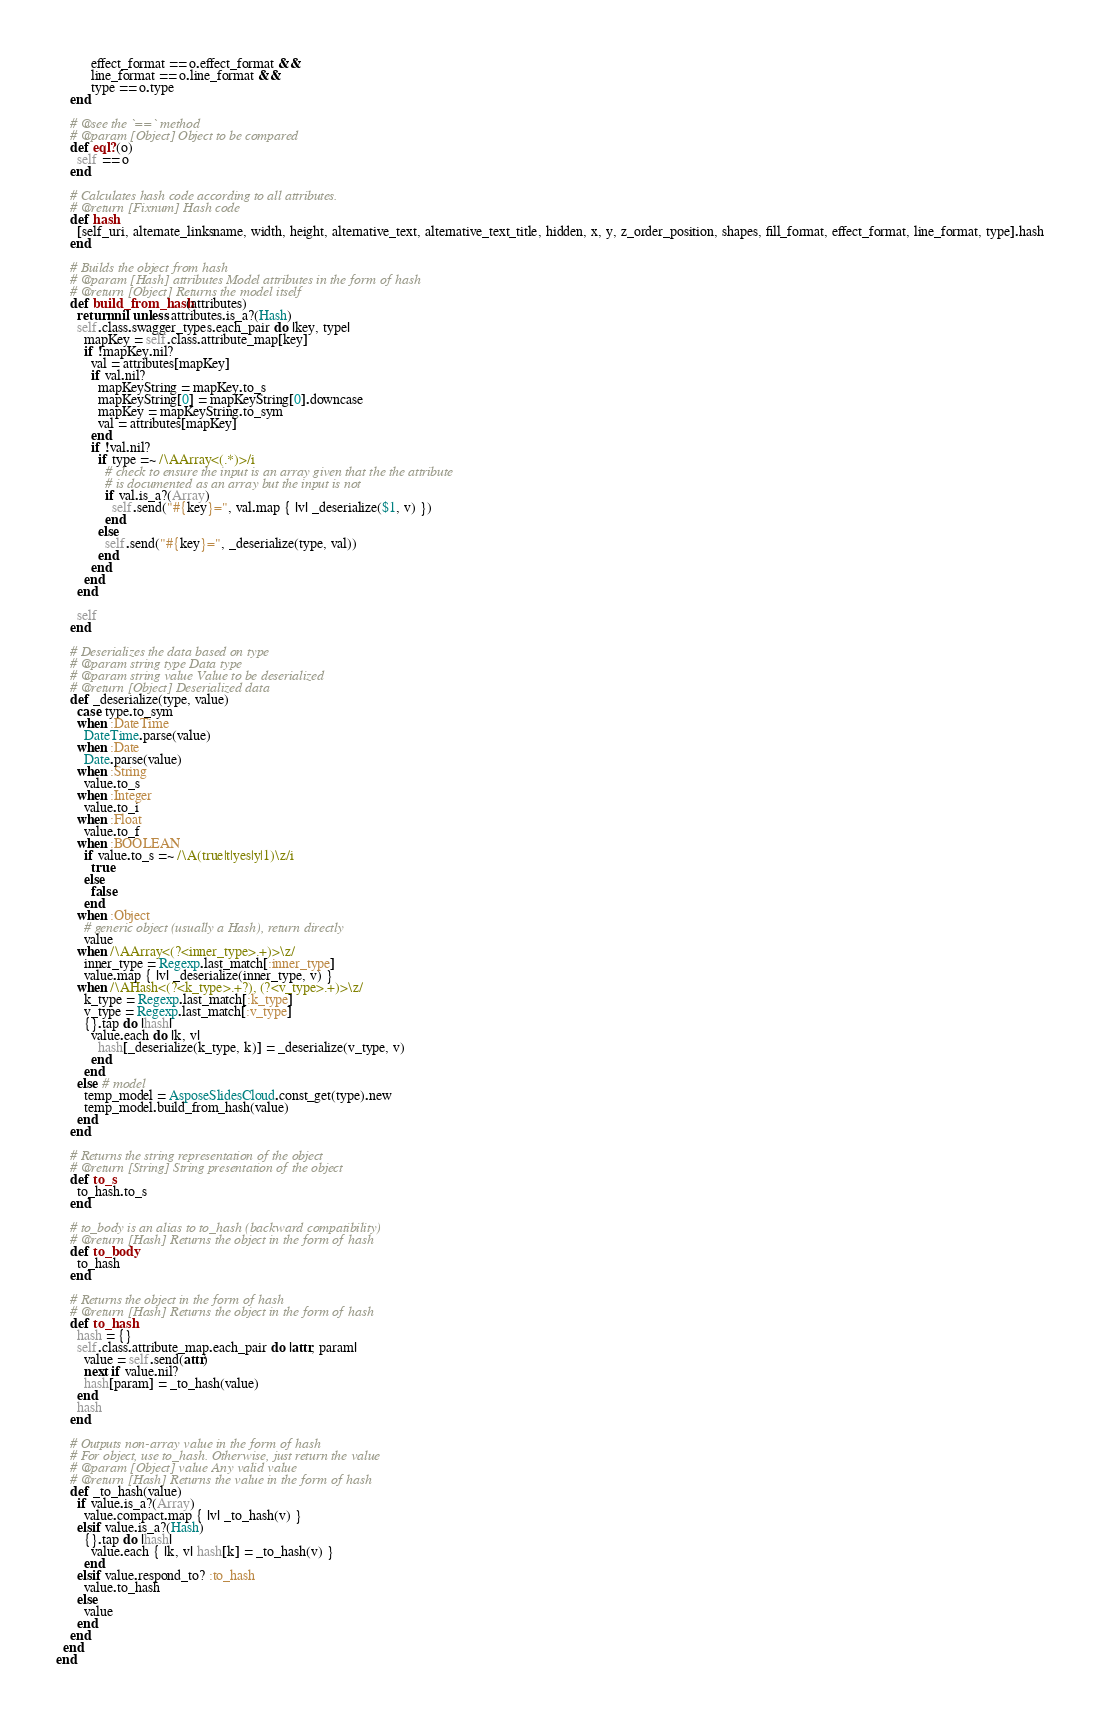Convert code to text. <code><loc_0><loc_0><loc_500><loc_500><_Ruby_>          effect_format == o.effect_format &&
          line_format == o.line_format &&
          type == o.type
    end

    # @see the `==` method
    # @param [Object] Object to be compared
    def eql?(o)
      self == o
    end

    # Calculates hash code according to all attributes.
    # @return [Fixnum] Hash code
    def hash
      [self_uri, alternate_linksname, width, height, alternative_text, alternative_text_title, hidden, x, y, z_order_position, shapes, fill_format, effect_format, line_format, type].hash
    end

    # Builds the object from hash
    # @param [Hash] attributes Model attributes in the form of hash
    # @return [Object] Returns the model itself
    def build_from_hash(attributes)
      return nil unless attributes.is_a?(Hash)
      self.class.swagger_types.each_pair do |key, type|
        mapKey = self.class.attribute_map[key]
        if !mapKey.nil?
          val = attributes[mapKey]
          if val.nil?
            mapKeyString = mapKey.to_s
            mapKeyString[0] = mapKeyString[0].downcase
            mapKey = mapKeyString.to_sym
            val = attributes[mapKey]
          end
          if !val.nil?
            if type =~ /\AArray<(.*)>/i
              # check to ensure the input is an array given that the the attribute
              # is documented as an array but the input is not
              if val.is_a?(Array)
                self.send("#{key}=", val.map { |v| _deserialize($1, v) })
              end
            else
              self.send("#{key}=", _deserialize(type, val))
            end
          end
        end
      end

      self
    end

    # Deserializes the data based on type
    # @param string type Data type
    # @param string value Value to be deserialized
    # @return [Object] Deserialized data
    def _deserialize(type, value)
      case type.to_sym
      when :DateTime
        DateTime.parse(value)
      when :Date
        Date.parse(value)
      when :String
        value.to_s
      when :Integer
        value.to_i
      when :Float
        value.to_f
      when :BOOLEAN
        if value.to_s =~ /\A(true|t|yes|y|1)\z/i
          true
        else
          false
        end
      when :Object
        # generic object (usually a Hash), return directly
        value
      when /\AArray<(?<inner_type>.+)>\z/
        inner_type = Regexp.last_match[:inner_type]
        value.map { |v| _deserialize(inner_type, v) }
      when /\AHash<(?<k_type>.+?), (?<v_type>.+)>\z/
        k_type = Regexp.last_match[:k_type]
        v_type = Regexp.last_match[:v_type]
        {}.tap do |hash|
          value.each do |k, v|
            hash[_deserialize(k_type, k)] = _deserialize(v_type, v)
          end
        end
      else # model
        temp_model = AsposeSlidesCloud.const_get(type).new
        temp_model.build_from_hash(value)
      end
    end

    # Returns the string representation of the object
    # @return [String] String presentation of the object
    def to_s
      to_hash.to_s
    end

    # to_body is an alias to to_hash (backward compatibility)
    # @return [Hash] Returns the object in the form of hash
    def to_body
      to_hash
    end

    # Returns the object in the form of hash
    # @return [Hash] Returns the object in the form of hash
    def to_hash
      hash = {}
      self.class.attribute_map.each_pair do |attr, param|
        value = self.send(attr)
        next if value.nil?
        hash[param] = _to_hash(value)
      end
      hash
    end

    # Outputs non-array value in the form of hash
    # For object, use to_hash. Otherwise, just return the value
    # @param [Object] value Any valid value
    # @return [Hash] Returns the value in the form of hash
    def _to_hash(value)
      if value.is_a?(Array)
        value.compact.map { |v| _to_hash(v) }
      elsif value.is_a?(Hash)
        {}.tap do |hash|
          value.each { |k, v| hash[k] = _to_hash(v) }
        end
      elsif value.respond_to? :to_hash
        value.to_hash
      else
        value
      end
    end
  end
end
</code> 